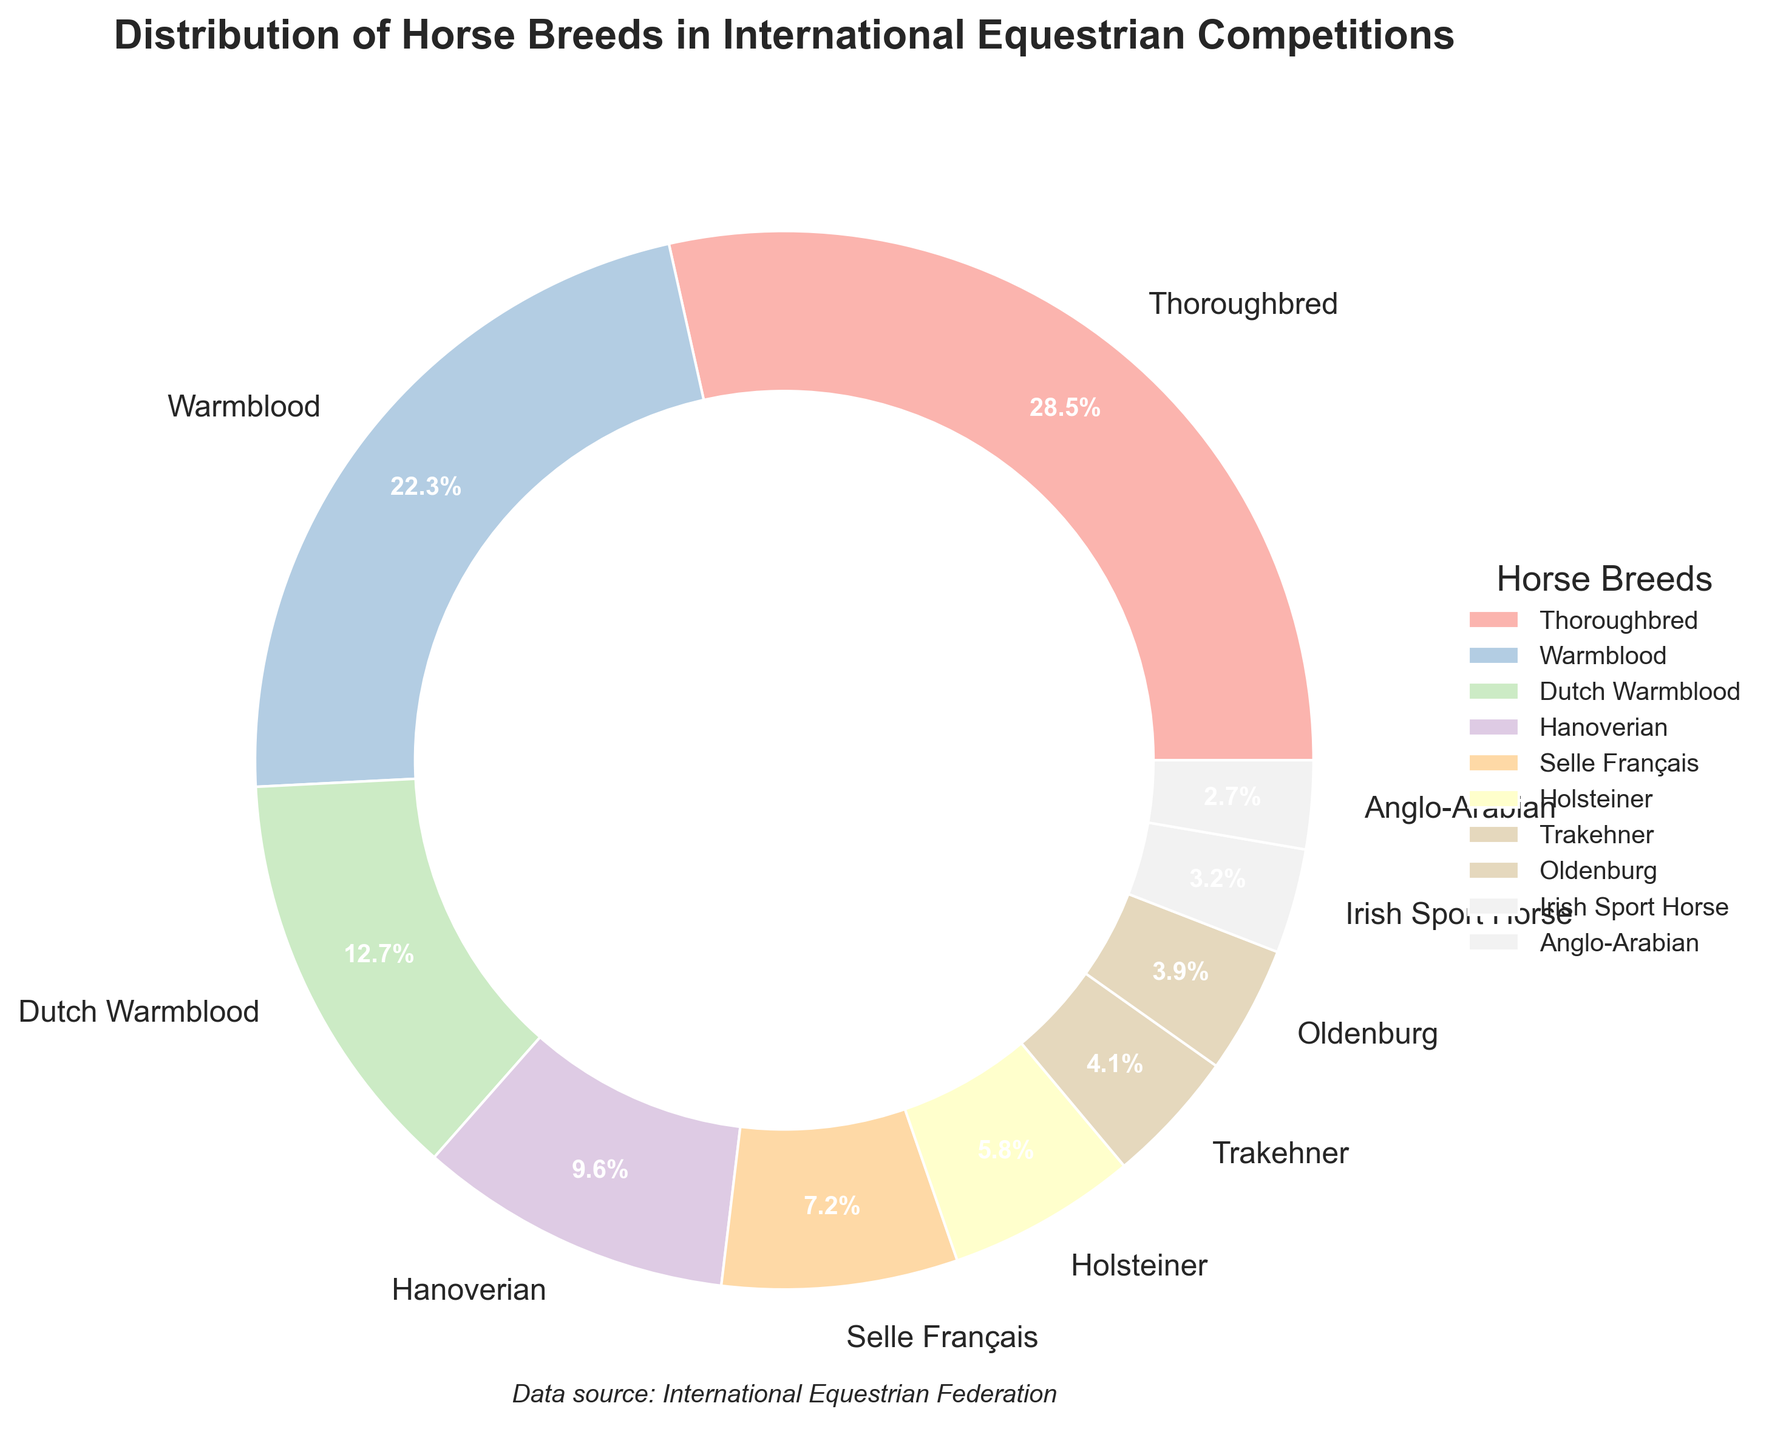Which breed has the highest percentage in international equestrian competitions? The figure shows the distribution of horse breeds in a pie chart. Observing the chart, Thoroughbred has the largest segment.
Answer: Thoroughbred What is the combined percentage of Warmblood and Dutch Warmblood? To find the combined percentage, add the two percentages: Warmblood (22.3%) + Dutch Warmblood (12.7%) = 35%.
Answer: 35% Which breed has a smaller percentage, Trakehner or Oldenburg? Look at the pie chart segments for Trakehner (4.1%) and Oldenburg (3.9%). The segment for Oldenburg is smaller.
Answer: Oldenburg How much more percentage does Thoroughbred have compared to Selle Français? Subtract the smaller percentage from the larger one: Thoroughbred (28.5%) - Selle Français (7.2%) = 21.3%.
Answer: 21.3% What is the average percentage of the top three breeds in the distribution? Add the percentages of the top three breeds and divide by three: (28.5% + 22.3% + 12.7%) / 3 = 63.5% / 3 = 21.17%.
Answer: 21.17% Are there any breeds with a percentage below 3%? If yes, which ones? Look at the pie chart for segments less than 3%. Anglo-Arabian (2.7%) and Irish Sport Horse (3.2%), only Anglo-Arabian is below 3%.
Answer: Anglo-Arabian Which breed category forms the second largest segment of the chart? Observing the pie chart, after Thoroughbred, Warmblood has the second largest segment at 22.3%.
Answer: Warmblood What is the percentage difference between Hanoverian and Holsteiner breeds? Subtract Holsteiner's percentage from Hanoverian's: Hanoverian (9.6%) - Holsteiner (5.8%) = 3.8%.
Answer: 3.8% How many breeds have a percentage representation higher than 10%? Observing the pie chart, Thoroughbred (28.5%), Warmblood (22.3%), and Dutch Warmblood (12.7%) have percentages higher than 10%. There are three breeds.
Answer: 3 Is the percentage of Anglo-Arabian breed more or less than half of Trakehner breed's percentage? Compare Anglo-Arabian (2.7%) with half of Trakehner (4.1% / 2 = 2.05%). Anglo-Arabian's percentage is more.
Answer: More 